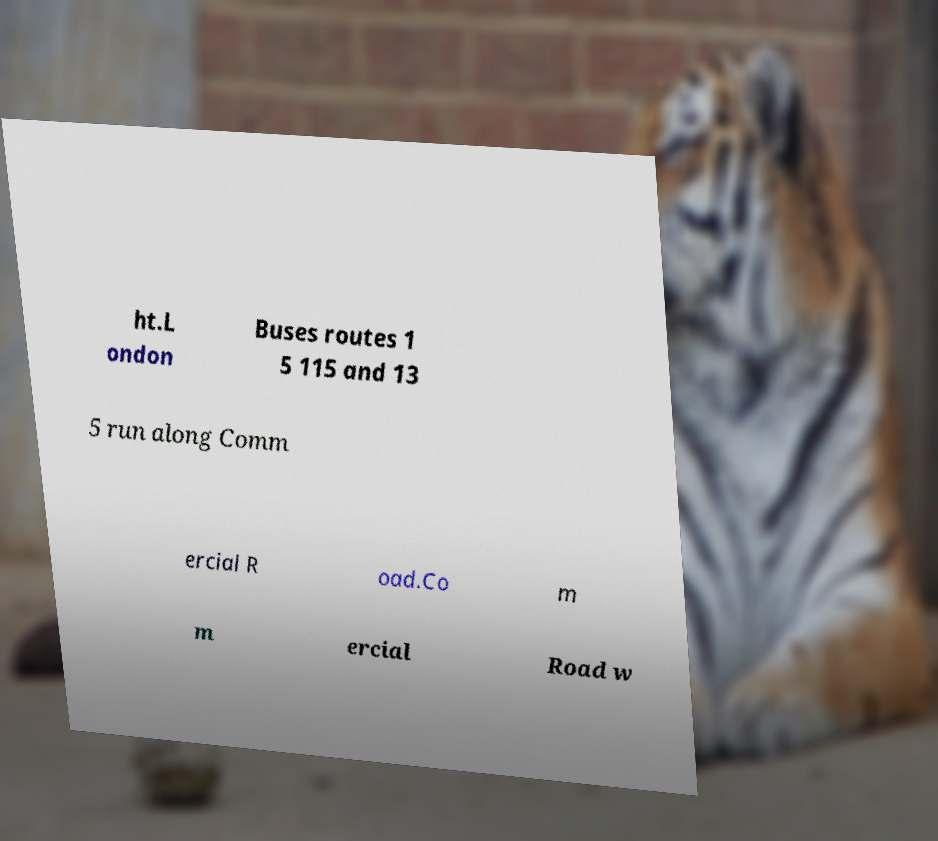Could you assist in decoding the text presented in this image and type it out clearly? ht.L ondon Buses routes 1 5 115 and 13 5 run along Comm ercial R oad.Co m m ercial Road w 